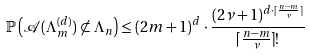Convert formula to latex. <formula><loc_0><loc_0><loc_500><loc_500>\mathbb { P } \left ( \mathcal { A } ( \Lambda _ { m } ^ { ( d ) } ) \not \subset \Lambda _ { n } \right ) \leq ( 2 m + 1 ) ^ { d } \cdot \frac { ( 2 \nu + 1 ) ^ { d \cdot \lceil \frac { n - m } { \nu } \rceil } } { \lceil \frac { n - m } { \nu } \rceil ! }</formula> 